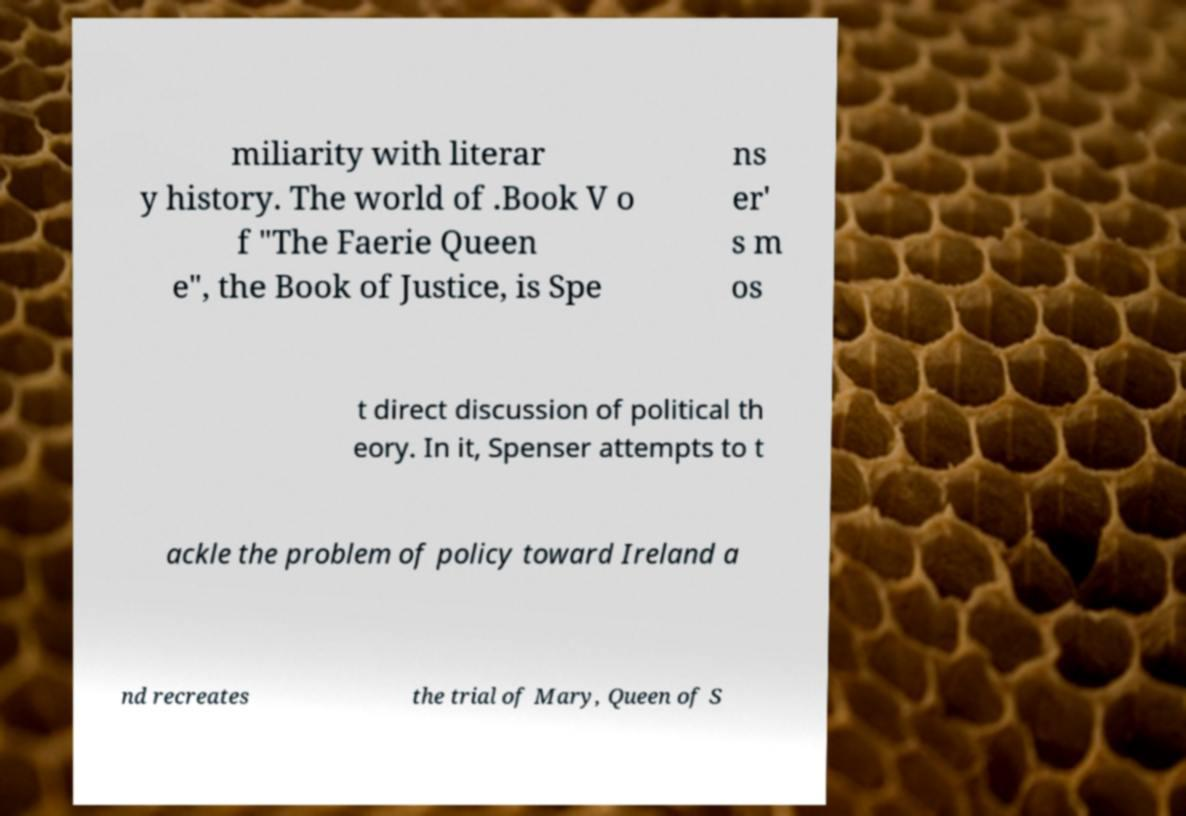Please read and relay the text visible in this image. What does it say? miliarity with literar y history. The world of .Book V o f "The Faerie Queen e", the Book of Justice, is Spe ns er' s m os t direct discussion of political th eory. In it, Spenser attempts to t ackle the problem of policy toward Ireland a nd recreates the trial of Mary, Queen of S 